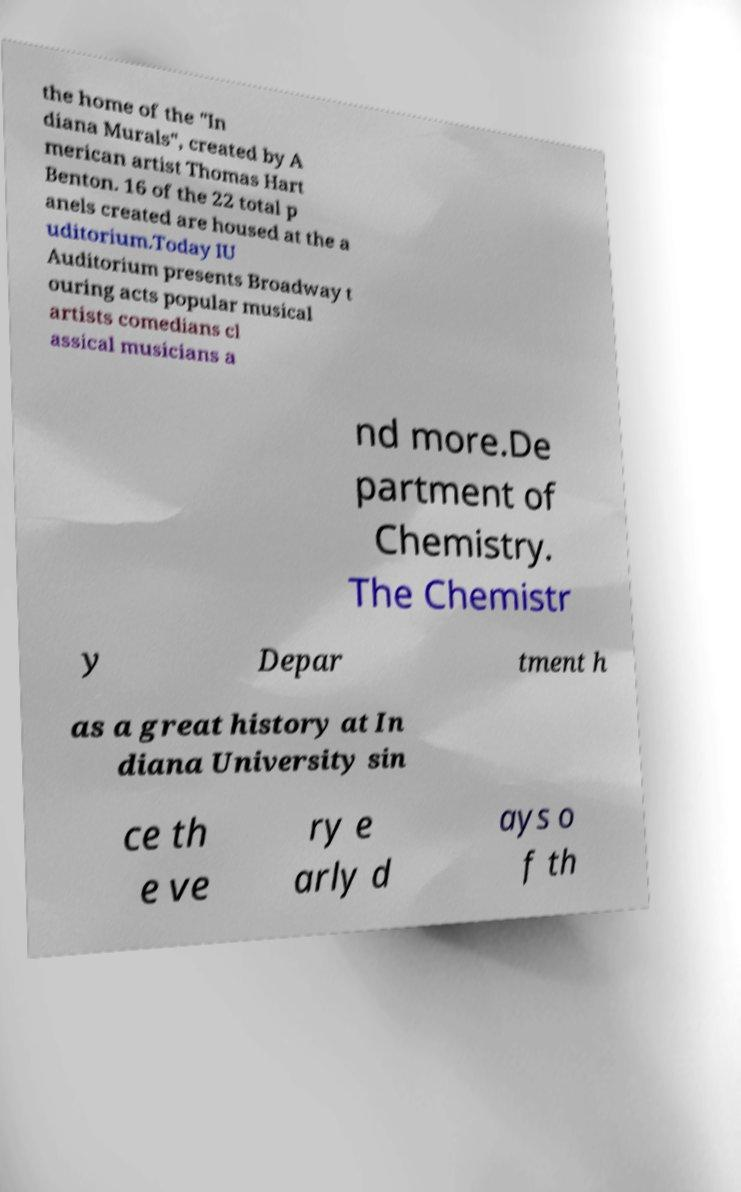Can you accurately transcribe the text from the provided image for me? the home of the "In diana Murals", created by A merican artist Thomas Hart Benton. 16 of the 22 total p anels created are housed at the a uditorium.Today IU Auditorium presents Broadway t ouring acts popular musical artists comedians cl assical musicians a nd more.De partment of Chemistry. The Chemistr y Depar tment h as a great history at In diana University sin ce th e ve ry e arly d ays o f th 